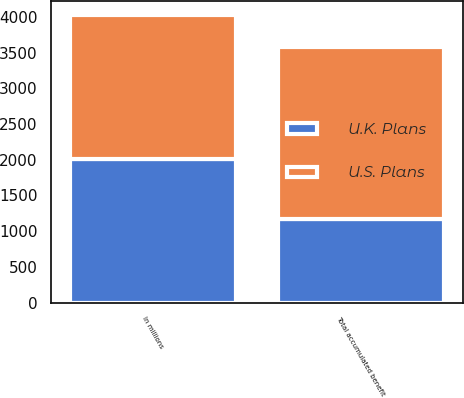Convert chart. <chart><loc_0><loc_0><loc_500><loc_500><stacked_bar_chart><ecel><fcel>In millions<fcel>Total accumulated benefit<nl><fcel>U.S. Plans<fcel>2012<fcel>2417<nl><fcel>U.K. Plans<fcel>2012<fcel>1167<nl></chart> 